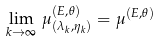Convert formula to latex. <formula><loc_0><loc_0><loc_500><loc_500>\lim _ { k \to \infty } \, \mu _ { ( \lambda _ { k } , \eta _ { k } ) } ^ { ( E , \theta ) } = \mu ^ { ( E , \theta ) }</formula> 